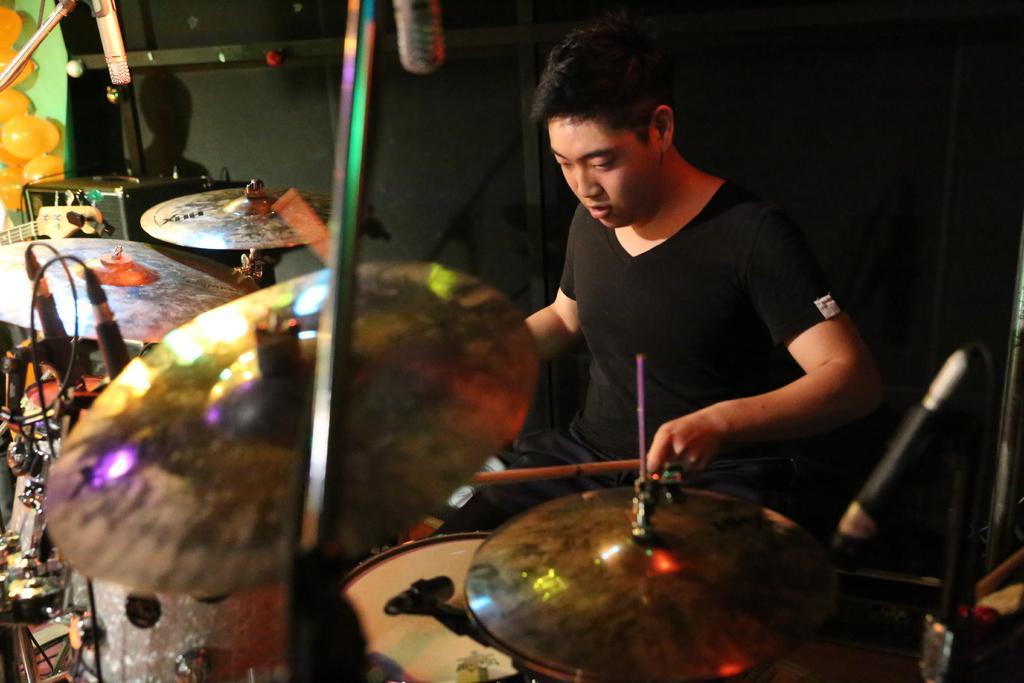Please provide a concise description of this image. In the center of the image we can see a man is sitting and holding the sticks and playing the musical instruments. In the background of the image we can see the wall, balloons, mics, stands, musical instruments. At the top, the image is dark. 